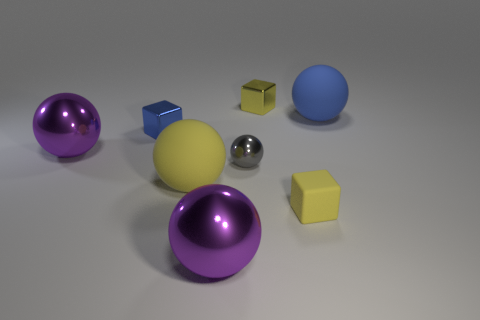Subtract all large yellow spheres. How many spheres are left? 4 Subtract all yellow spheres. How many spheres are left? 4 Subtract 1 spheres. How many spheres are left? 4 Subtract all red spheres. Subtract all gray cylinders. How many spheres are left? 5 Add 1 yellow metallic cubes. How many objects exist? 9 Subtract all balls. How many objects are left? 3 Subtract all small blue cubes. Subtract all matte blocks. How many objects are left? 6 Add 2 big purple things. How many big purple things are left? 4 Add 2 big purple balls. How many big purple balls exist? 4 Subtract 0 brown balls. How many objects are left? 8 